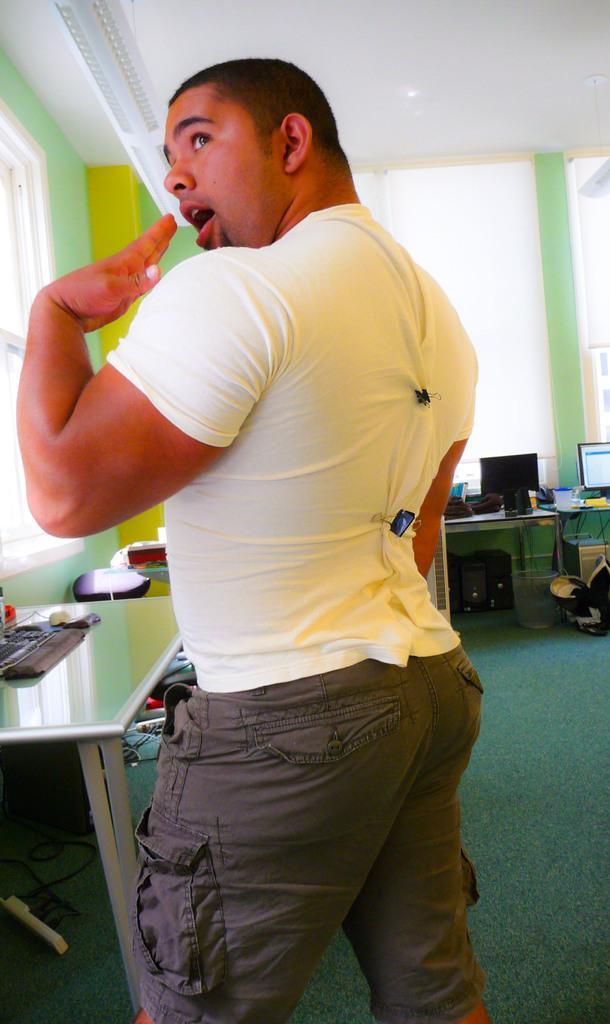Please provide a concise description of this image. In this image i can see a person standing. In the background i can see a table on which there is a monitor, a wall , a window and the ceiling. 